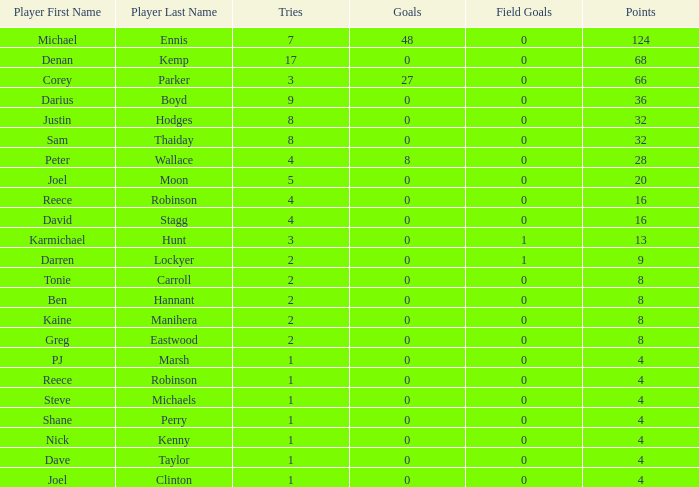What is the lowest tries the player with more than 0 goals, 28 points, and more than 0 field goals have? None. 